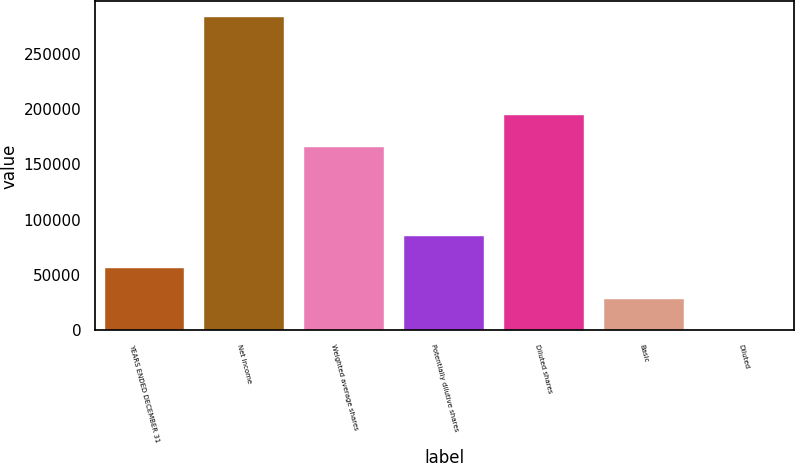Convert chart. <chart><loc_0><loc_0><loc_500><loc_500><bar_chart><fcel>YEARS ENDED DECEMBER 31<fcel>Net Income<fcel>Weighted average shares<fcel>Potentially dilutive shares<fcel>Diluted shares<fcel>Basic<fcel>Diluted<nl><fcel>56636.9<fcel>283178<fcel>166003<fcel>84954.5<fcel>194321<fcel>28319.3<fcel>1.65<nl></chart> 